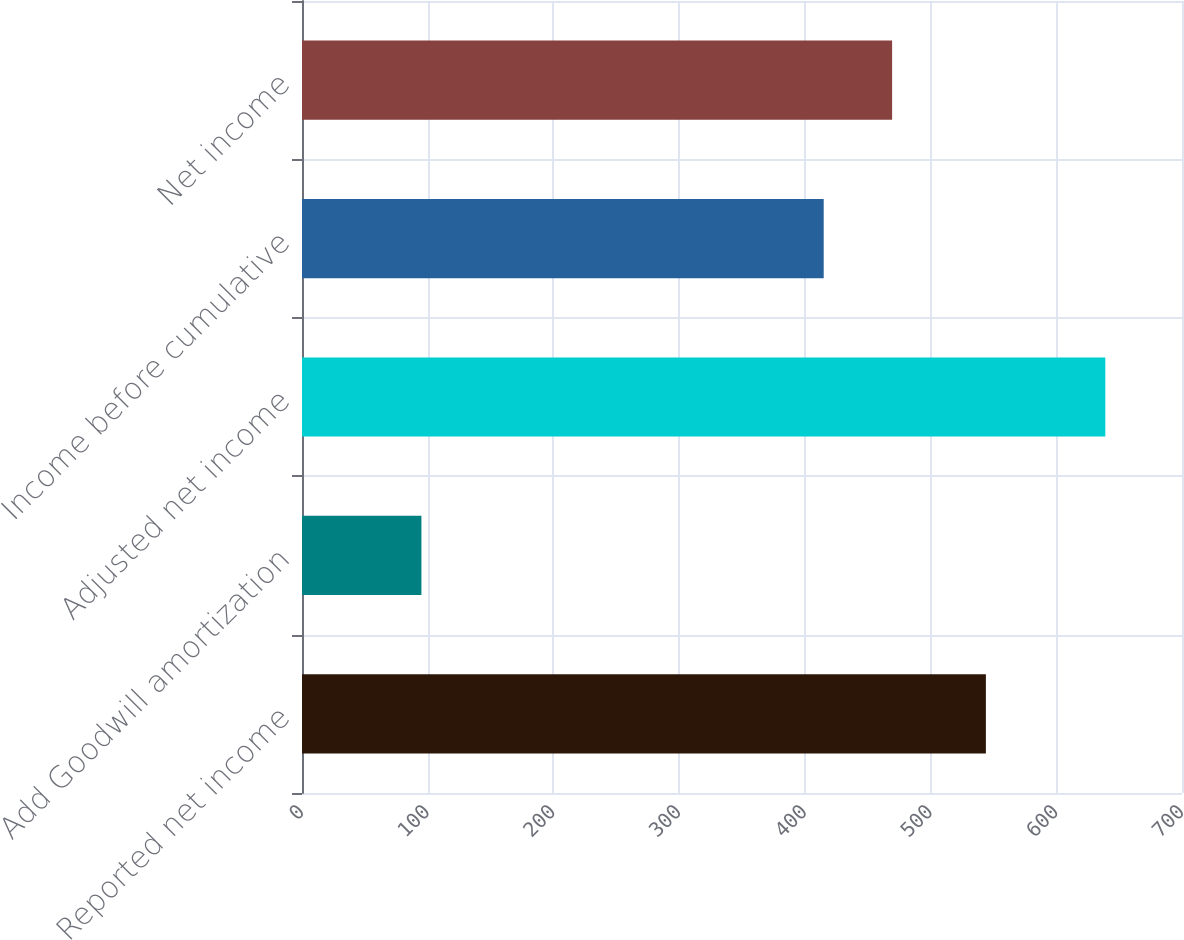Convert chart. <chart><loc_0><loc_0><loc_500><loc_500><bar_chart><fcel>Reported net income<fcel>Add Goodwill amortization<fcel>Adjusted net income<fcel>Income before cumulative<fcel>Net income<nl><fcel>544<fcel>95<fcel>639<fcel>415<fcel>469.4<nl></chart> 